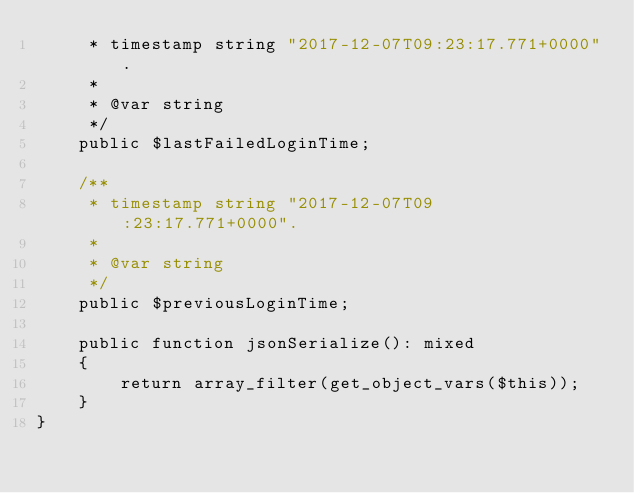Convert code to text. <code><loc_0><loc_0><loc_500><loc_500><_PHP_>     * timestamp string "2017-12-07T09:23:17.771+0000".
     *
     * @var string
     */
    public $lastFailedLoginTime;

    /**
     * timestamp string "2017-12-07T09:23:17.771+0000".
     *
     * @var string
     */
    public $previousLoginTime;

    public function jsonSerialize(): mixed
    {
        return array_filter(get_object_vars($this));
    }
}
</code> 